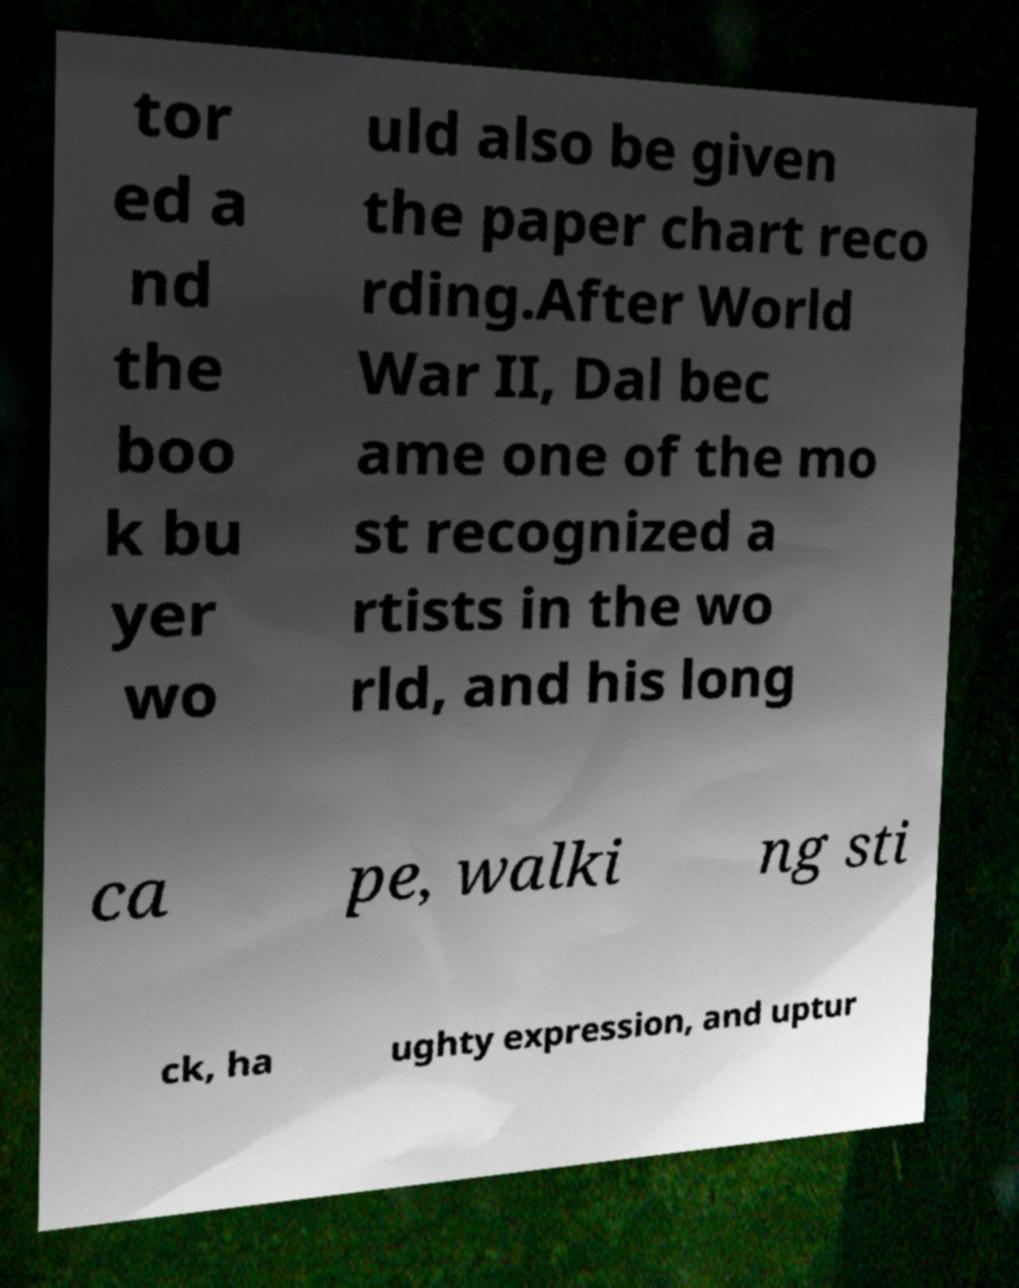What messages or text are displayed in this image? I need them in a readable, typed format. tor ed a nd the boo k bu yer wo uld also be given the paper chart reco rding.After World War II, Dal bec ame one of the mo st recognized a rtists in the wo rld, and his long ca pe, walki ng sti ck, ha ughty expression, and uptur 